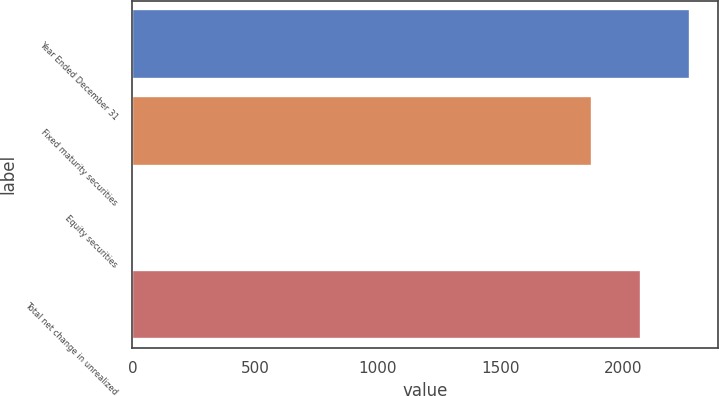Convert chart to OTSL. <chart><loc_0><loc_0><loc_500><loc_500><bar_chart><fcel>Year Ended December 31<fcel>Fixed maturity securities<fcel>Equity securities<fcel>Total net change in unrealized<nl><fcel>2272.4<fcel>1871<fcel>5<fcel>2071.7<nl></chart> 